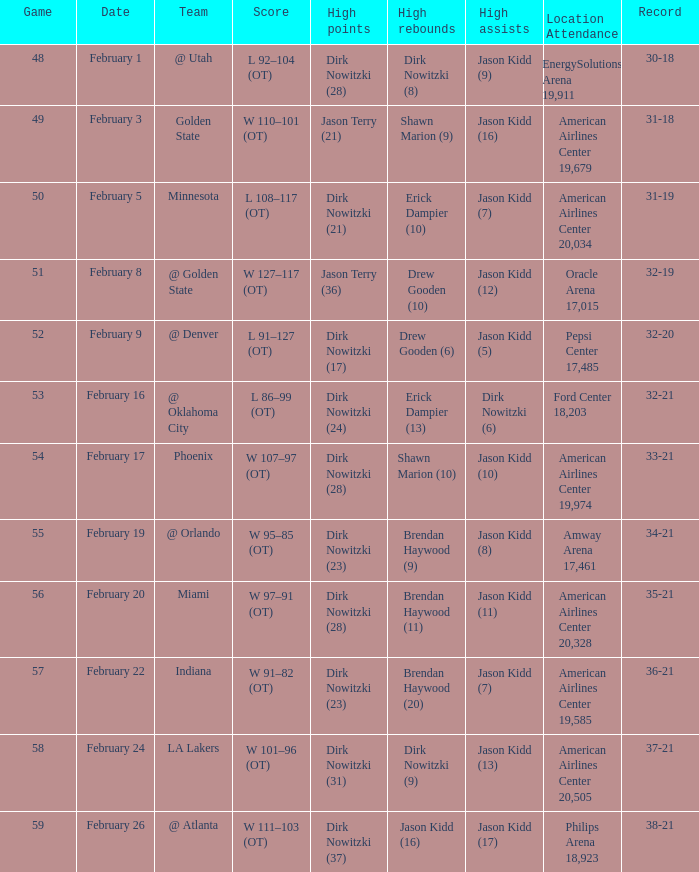At what point did the mavericks achieve a 32-19 record? February 8. 